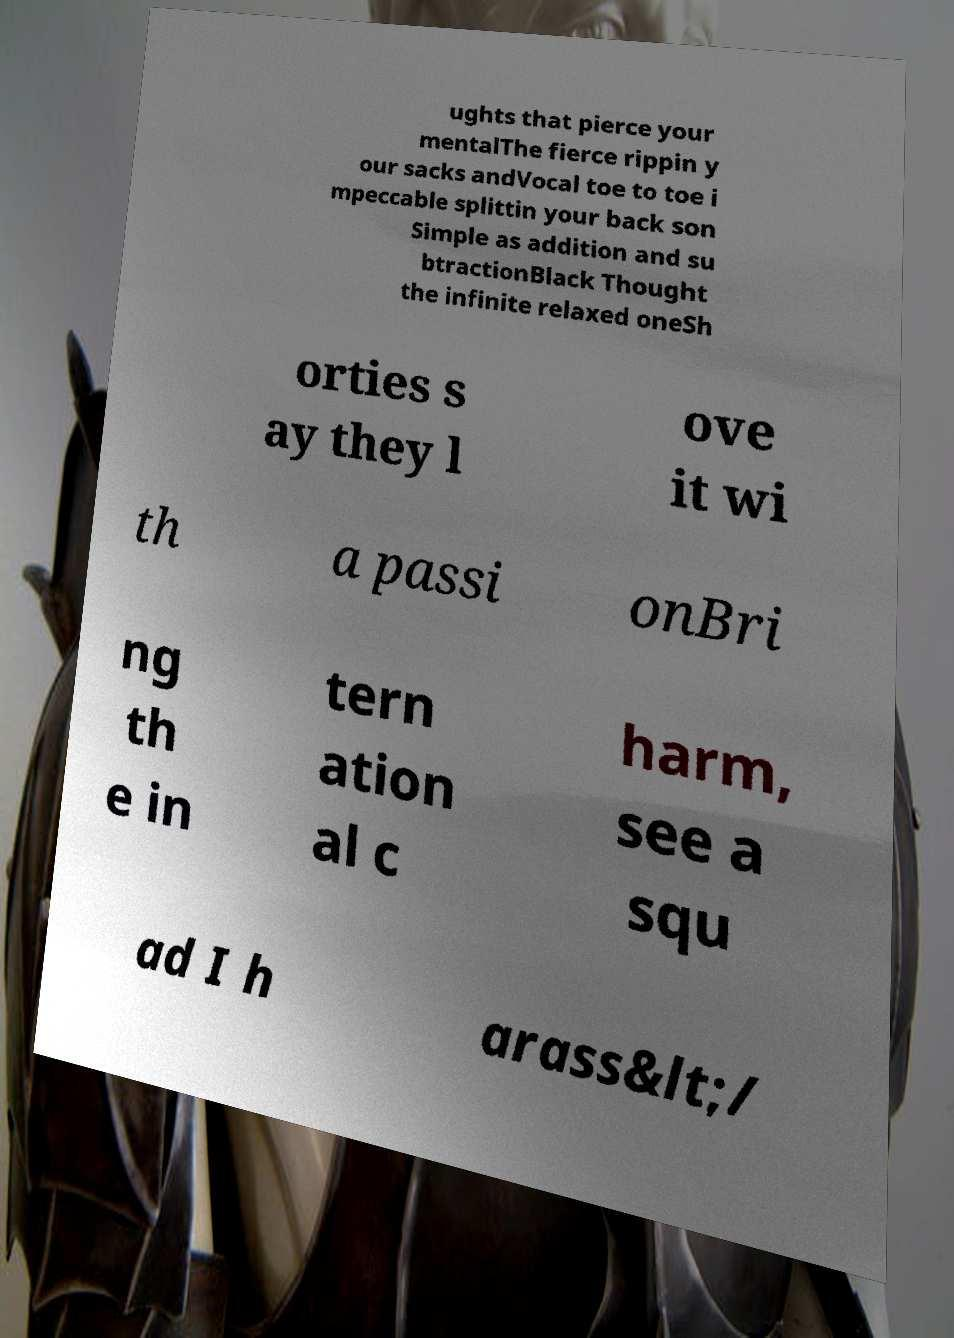What messages or text are displayed in this image? I need them in a readable, typed format. ughts that pierce your mentalThe fierce rippin y our sacks andVocal toe to toe i mpeccable splittin your back son Simple as addition and su btractionBlack Thought the infinite relaxed oneSh orties s ay they l ove it wi th a passi onBri ng th e in tern ation al c harm, see a squ ad I h arass&lt;/ 